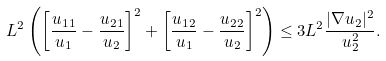<formula> <loc_0><loc_0><loc_500><loc_500>L ^ { 2 } \left ( \left [ \frac { u _ { 1 1 } } { u _ { 1 } } - \frac { u _ { 2 1 } } { u _ { 2 } } \right ] ^ { 2 } + \left [ \frac { u _ { 1 2 } } { u _ { 1 } } - \frac { u _ { 2 2 } } { u _ { 2 } } \right ] ^ { 2 } \right ) \leq 3 L ^ { 2 } \frac { | \nabla u _ { 2 } | ^ { 2 } } { u ^ { 2 } _ { 2 } } .</formula> 